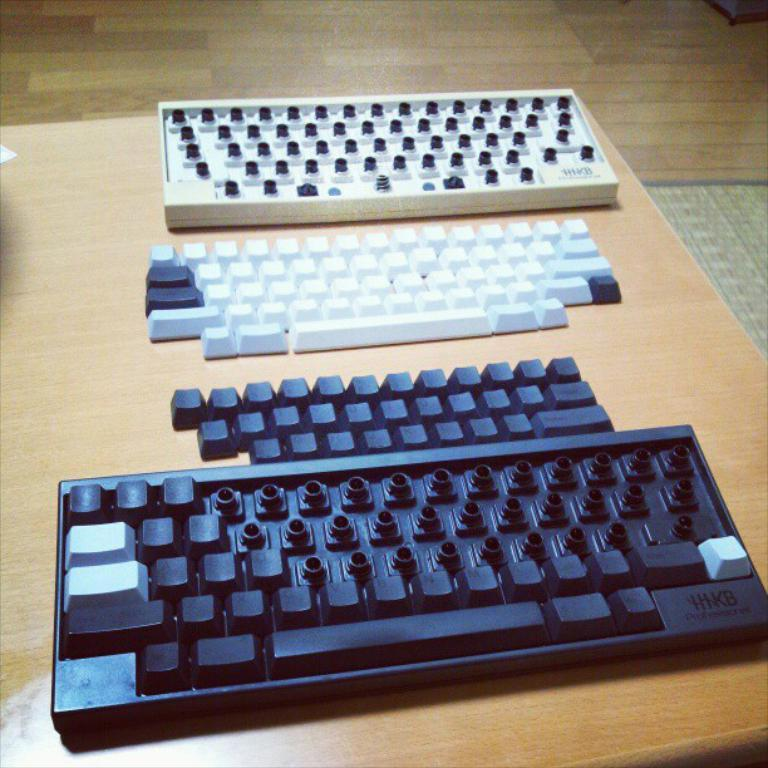<image>
Render a clear and concise summary of the photo. Black keyboard under a white keyboard that says "HKB" on the side. 